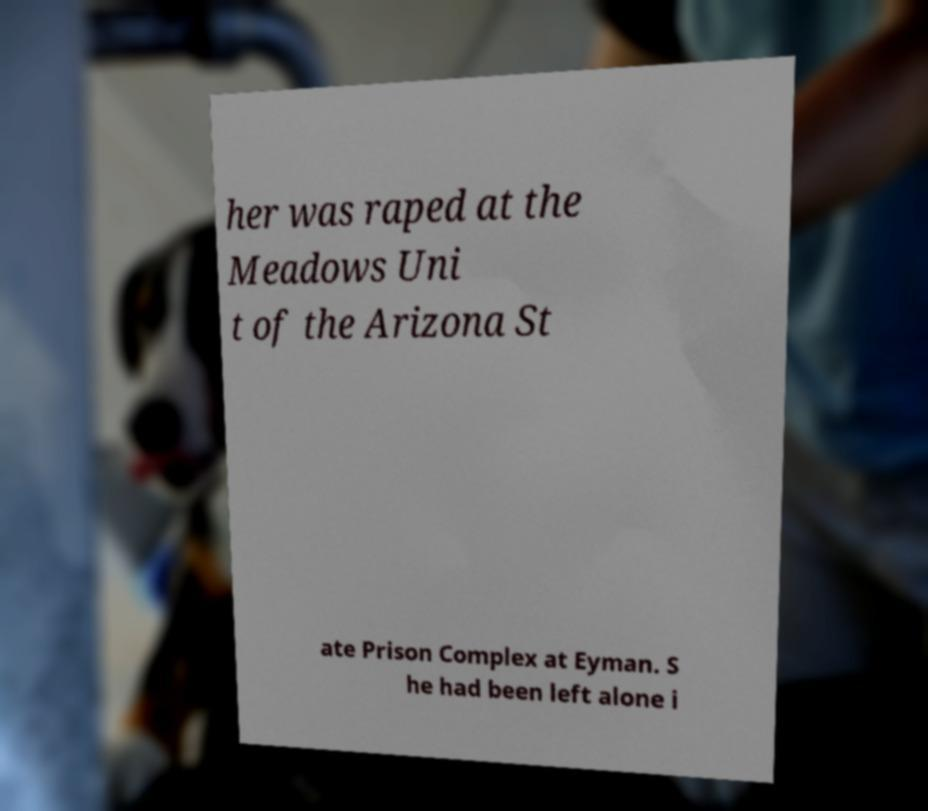Could you assist in decoding the text presented in this image and type it out clearly? her was raped at the Meadows Uni t of the Arizona St ate Prison Complex at Eyman. S he had been left alone i 